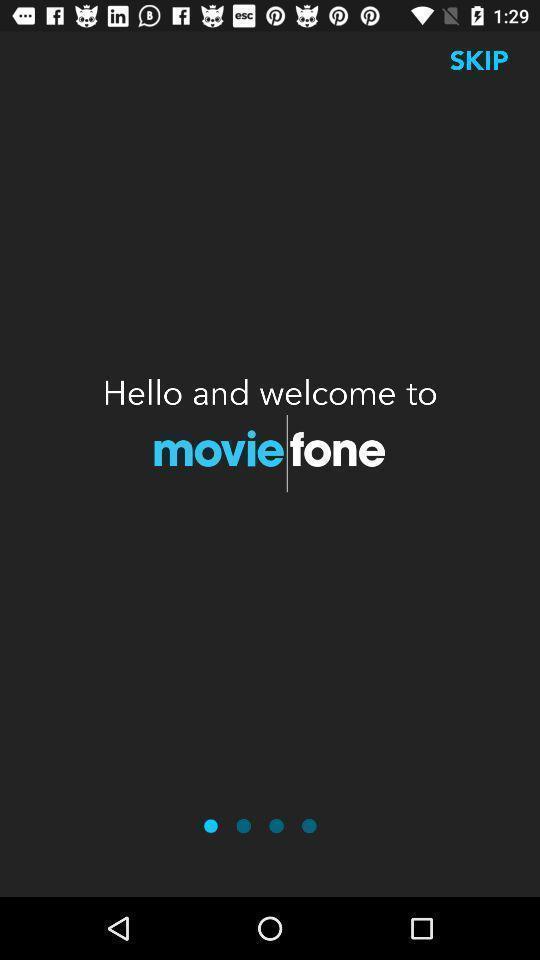Describe the content in this image. Welcome page. 